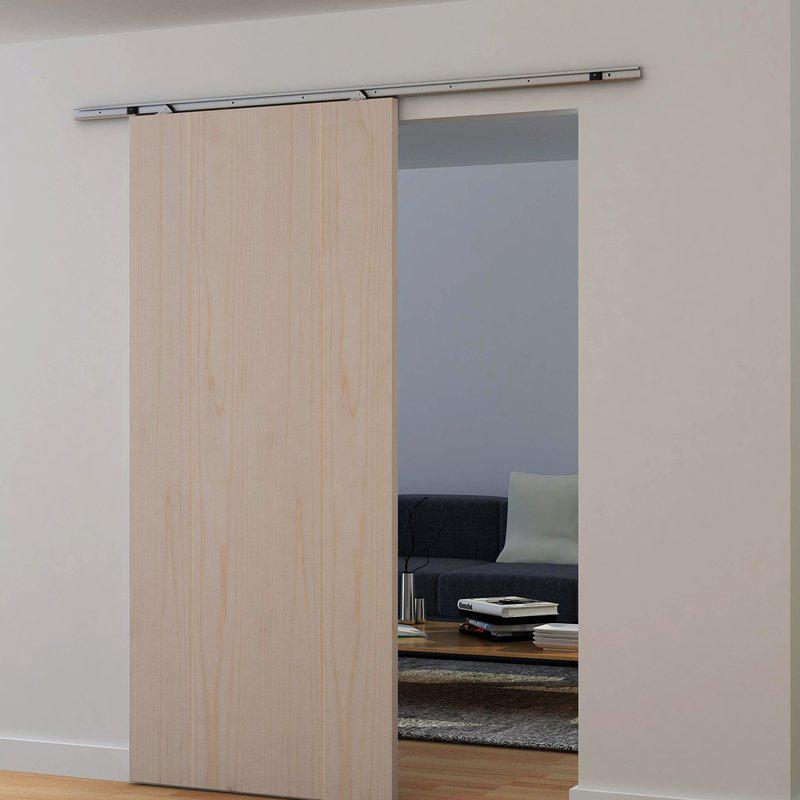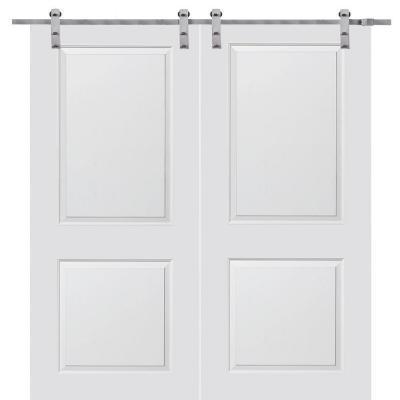The first image is the image on the left, the second image is the image on the right. Considering the images on both sides, is "The image on the right contains a potted plant" valid? Answer yes or no. No. 